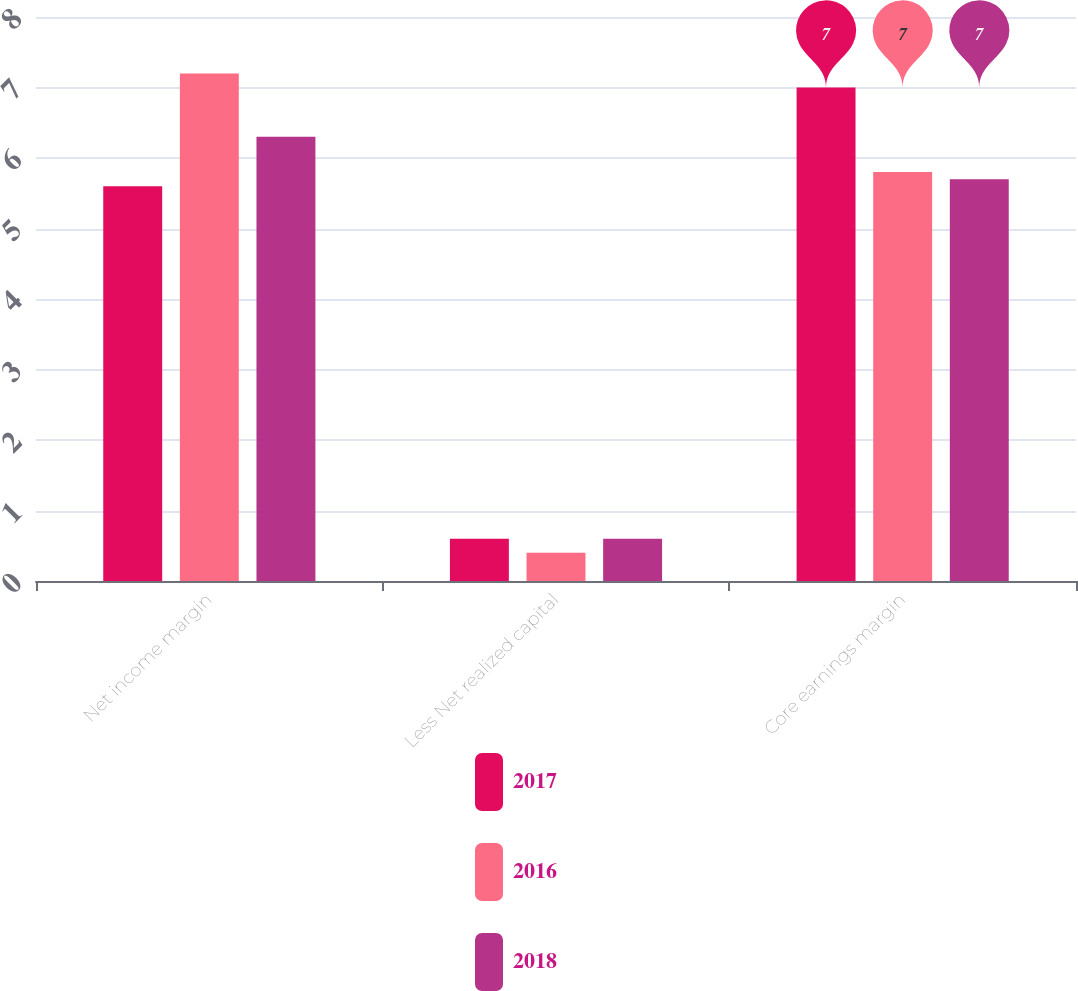Convert chart. <chart><loc_0><loc_0><loc_500><loc_500><stacked_bar_chart><ecel><fcel>Net income margin<fcel>Less Net realized capital<fcel>Core earnings margin<nl><fcel>2017<fcel>5.6<fcel>0.6<fcel>7<nl><fcel>2016<fcel>7.2<fcel>0.4<fcel>5.8<nl><fcel>2018<fcel>6.3<fcel>0.6<fcel>5.7<nl></chart> 